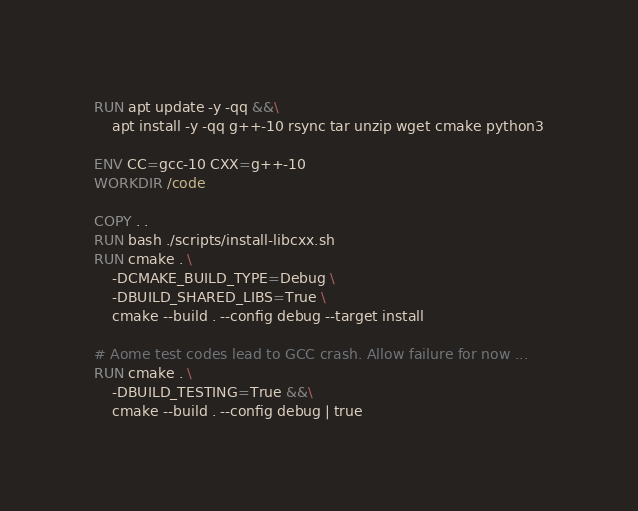Convert code to text. <code><loc_0><loc_0><loc_500><loc_500><_Dockerfile_>
RUN apt update -y -qq &&\
    apt install -y -qq g++-10 rsync tar unzip wget cmake python3

ENV CC=gcc-10 CXX=g++-10
WORKDIR /code

COPY . .
RUN bash ./scripts/install-libcxx.sh
RUN cmake . \
    -DCMAKE_BUILD_TYPE=Debug \
    -DBUILD_SHARED_LIBS=True \
    cmake --build . --config debug --target install

# Aome test codes lead to GCC crash. Allow failure for now ...
RUN cmake . \
    -DBUILD_TESTING=True &&\
    cmake --build . --config debug | true
</code> 